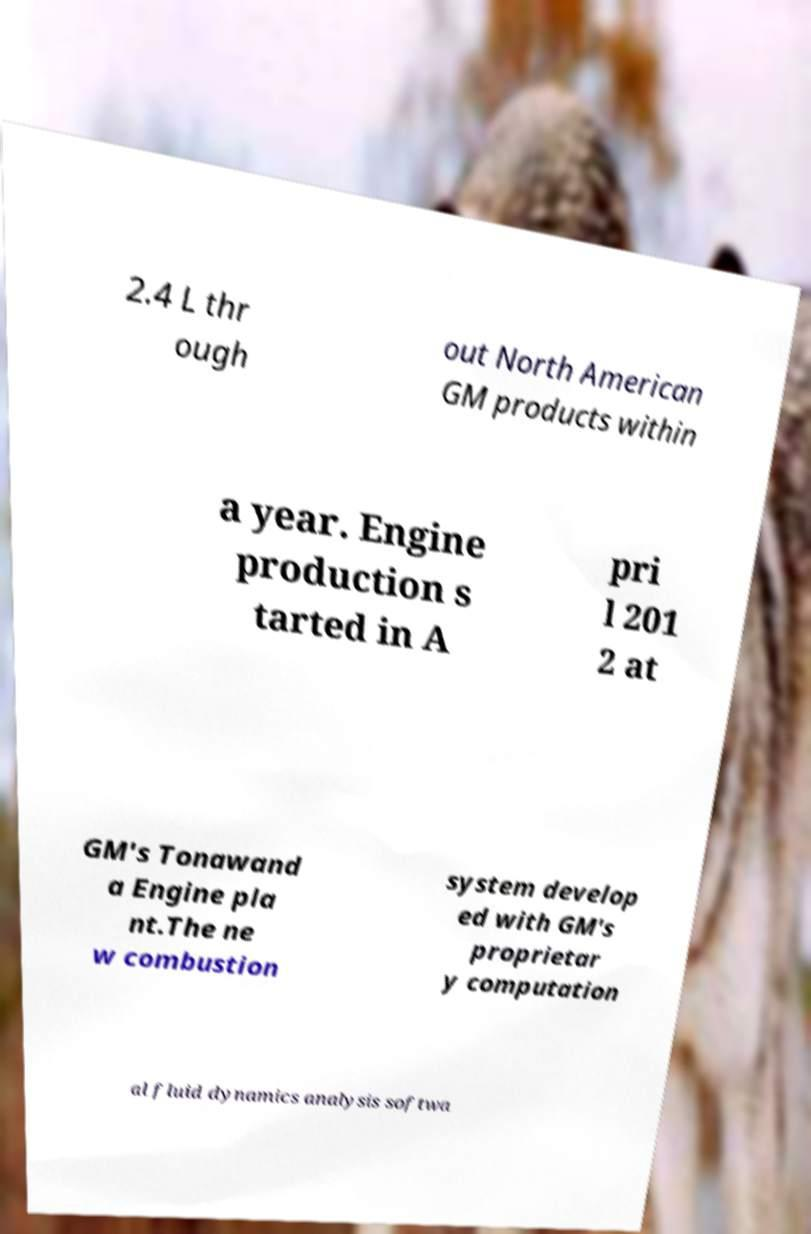There's text embedded in this image that I need extracted. Can you transcribe it verbatim? 2.4 L thr ough out North American GM products within a year. Engine production s tarted in A pri l 201 2 at GM's Tonawand a Engine pla nt.The ne w combustion system develop ed with GM's proprietar y computation al fluid dynamics analysis softwa 